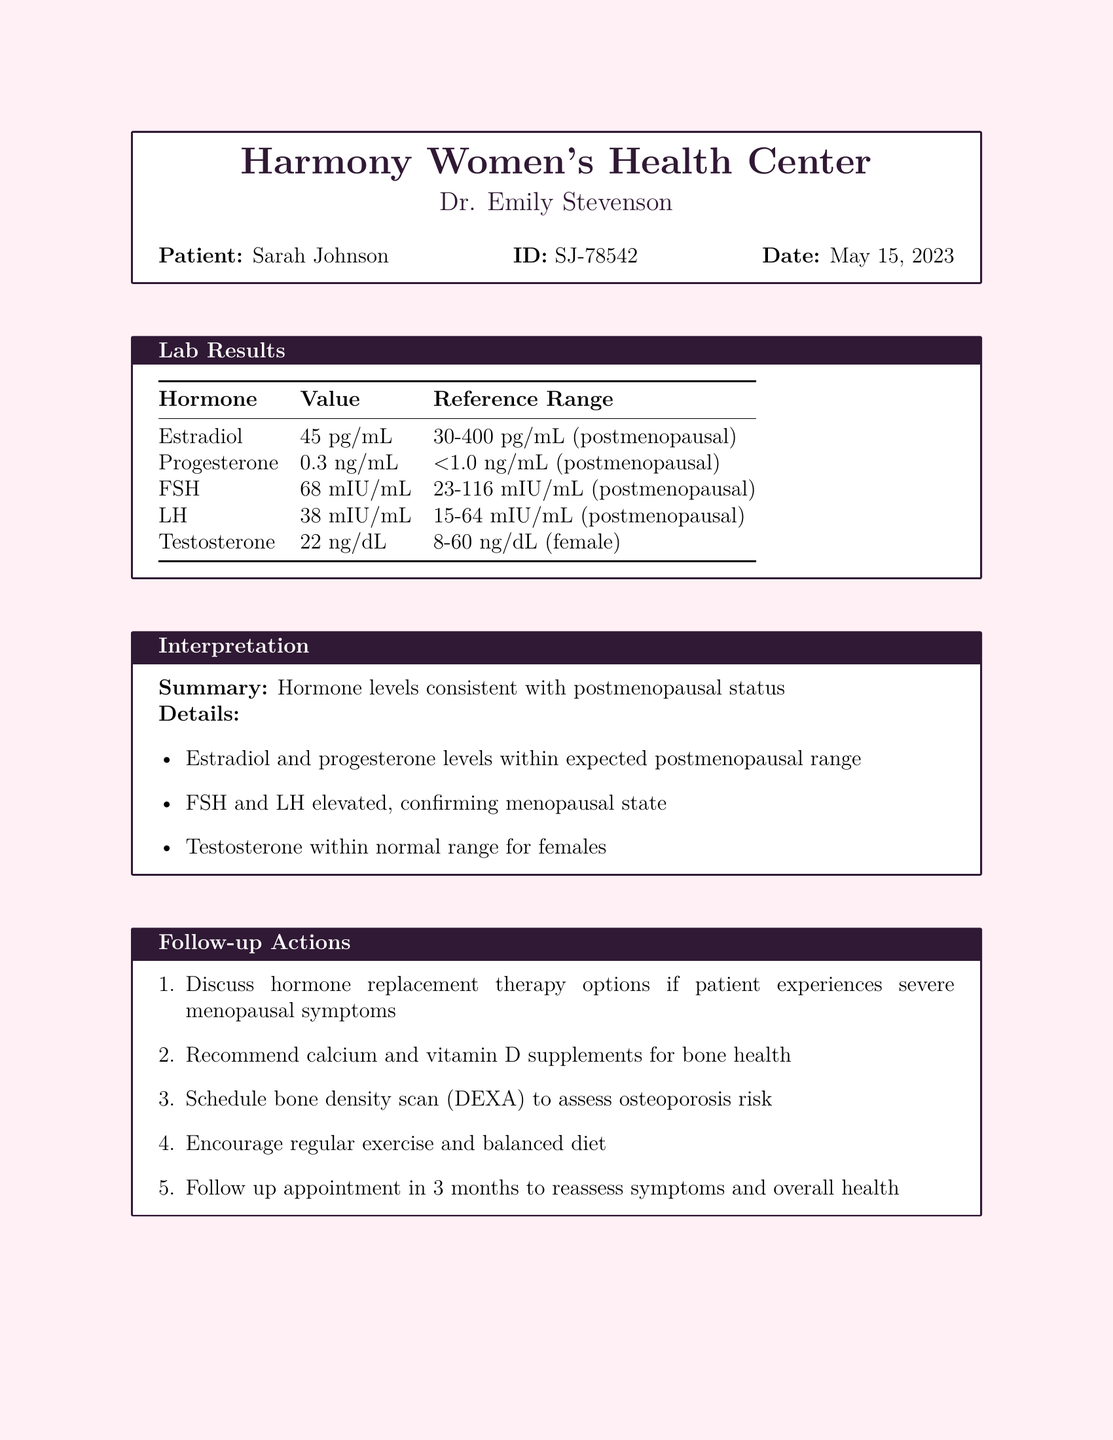What is the patient's name? The patient's name is listed under the patient information section of the document.
Answer: Sarah Johnson What is the date of the lab report? The date is specified in the patient information section of the document.
Answer: May 15, 2023 What is the value of Estradiol? The value of Estradiol is found in the lab results table.
Answer: 45 pg/mL What is the interpretation summary? The summary gives an overview of hormone levels based on the interpretation section.
Answer: Hormone levels consistent with postmenopausal status What should be done for bone health? This recommendation is mentioned in the follow-up actions section.
Answer: Recommend calcium and vitamin D supplements What is the hormone that confirms menopausal state? This can be inferred from the details provided in the interpretation section about elevated levels.
Answer: FSH and LH How often should the follow-up appointment be scheduled? This information is presented in the follow-up actions section of the document.
Answer: 3 months What therapy options should be discussed if the patient experiences symptoms? This is indicated in the follow-up actions section discussing treatment.
Answer: Hormone replacement therapy options 